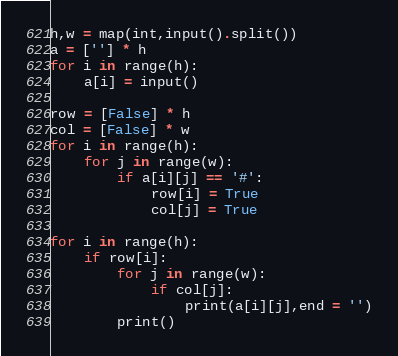<code> <loc_0><loc_0><loc_500><loc_500><_Python_>h,w = map(int,input().split())
a = [''] * h
for i in range(h):
    a[i] = input()

row = [False] * h
col = [False] * w
for i in range(h):
    for j in range(w):
        if a[i][j] == '#':
            row[i] = True
            col[j] = True

for i in range(h):
    if row[i]:
        for j in range(w):
            if col[j]:
                print(a[i][j],end = '')
        print()
</code> 